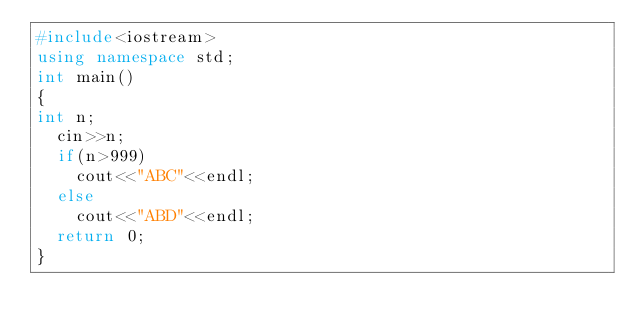<code> <loc_0><loc_0><loc_500><loc_500><_C++_>#include<iostream>
using namespace std;
int main()
{
int n;
  cin>>n;
  if(n>999)
    cout<<"ABC"<<endl;
  else 
    cout<<"ABD"<<endl;
  return 0;
}</code> 